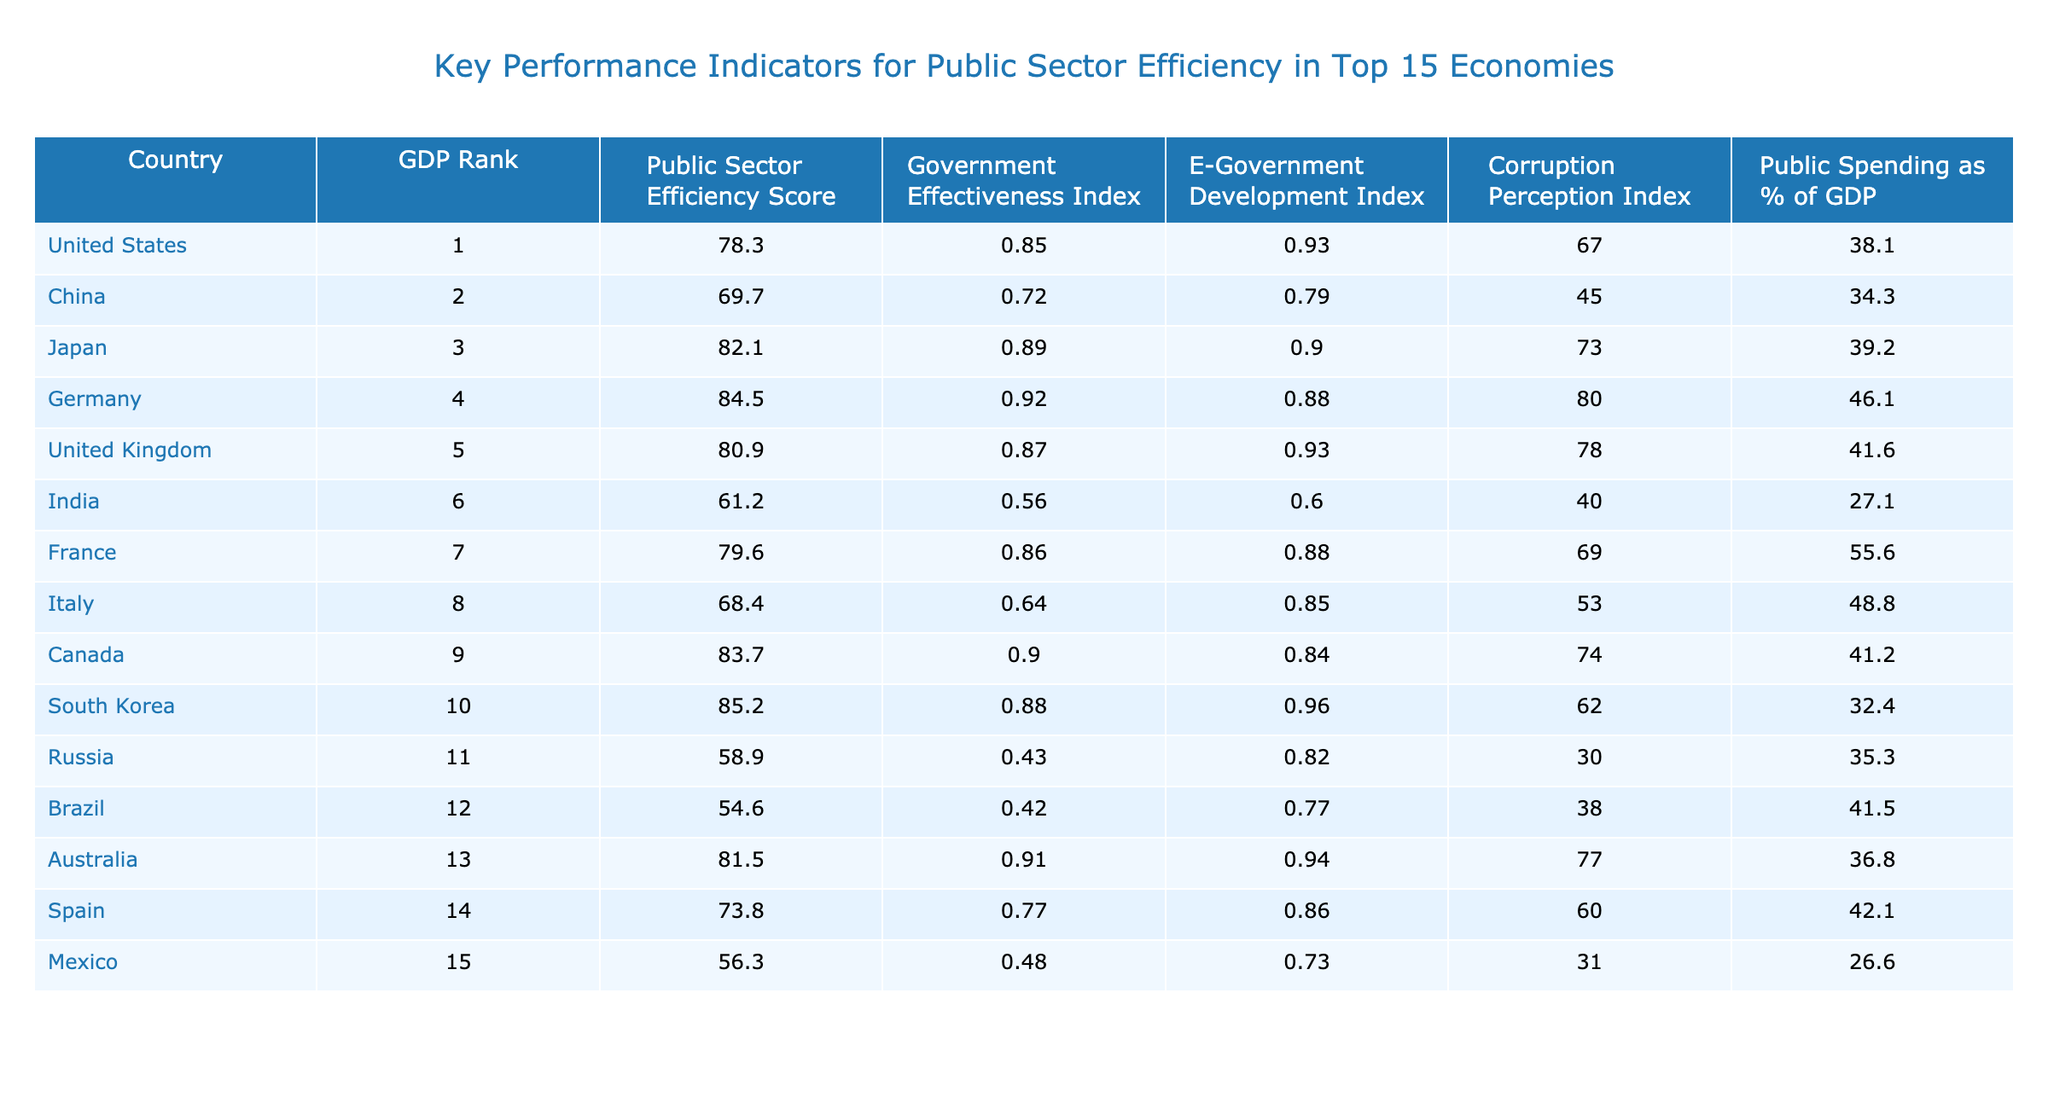What is the Public Sector Efficiency Score for Germany? The table shows a specific column for Public Sector Efficiency Score. By looking at the row for Germany, the score is listed as 84.5.
Answer: 84.5 Which country has the highest Government Effectiveness Index? The Government Effectiveness Index is also listed in the table, and Germany has the highest value of 0.92.
Answer: Germany What is the average Public Sector Efficiency Score for the top 15 economies? To find the average, first sum all the Public Sector Efficiency Scores: 78.3 + 69.7 + 82.1 + 84.5 + 80.9 + 61.2 + 79.6 + 68.4 + 83.7 + 85.2 + 58.9 + 54.6 + 81.5 + 73.8 + 56.3 = 81.0. There are 15 countries, so the average is 81.0 / 15 = 78.73.
Answer: 78.73 Which country has the lowest Corruption Perception Index? The table illustrates a specific column for the Corruption Perception Index. Looking through this column, Russia has the lowest score of 30.
Answer: Russia Is the Public Spending as % of GDP for China higher than that for India? The table shows Public Spending as a percentage of GDP for China (34.3) and for India (27.1). Since 34.3 is greater than 27.1, the statement is true.
Answer: Yes What is the difference between the Public Sector Efficiency Scores of the United States and Brazil? The Public Sector Efficiency Score for the United States is 78.3, and for Brazil, it is 54.6. To find the difference, subtract Brazil's score from the United States' score: 78.3 - 54.6 = 23.7.
Answer: 23.7 Which country has both a high Public Sector Efficiency Score and a high E-Government Development Index? By examining the table, we see that Germany has a Public Sector Efficiency Score of 84.5 and an E-Government Development Index of 0.88, making it one of the countries that fit this criterion.
Answer: Germany Is India's Public Sector Efficiency Score above the median of all key performance indicators? First, we need to find the median score among the 15 countries. The scores listed, when ordered, show that the median is the average of the 7th and 8th scores when sorted (79.6 and 78.4), which is 78.0. India's score of 61.2 is below this median.
Answer: No How does the Government Effectiveness Index of Canada compare to that of Italy? The table shows Canada's score as 0.90 and Italy's score as 0.64. Therefore, Canada's effectiveness is higher than Italy's.
Answer: Canada is higher Which country has the highest Public Spending as % of GDP in the table? By reviewing the Public Spending column in the table, France has the highest percentage at 55.6%.
Answer: France 